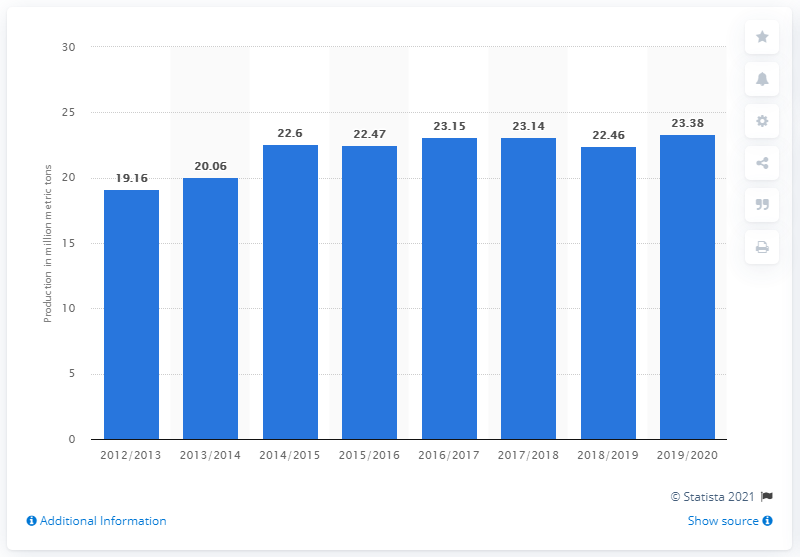Highlight a few significant elements in this photo. During the marketing year 2019/2020, the global production of grapes was 23.15 million metric tons. 